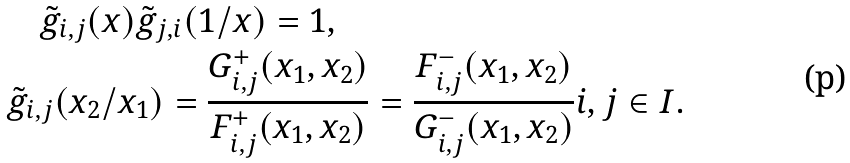Convert formula to latex. <formula><loc_0><loc_0><loc_500><loc_500>& \quad \tilde { g } _ { i , j } ( x ) \tilde { g } _ { j , i } ( 1 / x ) = 1 , \\ & \tilde { g } _ { i , j } ( x _ { 2 } / x _ { 1 } ) = \frac { G ^ { + } _ { i , j } ( x _ { 1 } , x _ { 2 } ) } { F ^ { + } _ { i , j } ( x _ { 1 } , x _ { 2 } ) } = \frac { F ^ { - } _ { i , j } ( x _ { 1 } , x _ { 2 } ) } { G ^ { - } _ { i , j } ( x _ { 1 } , x _ { 2 } ) } i , j \in I .</formula> 